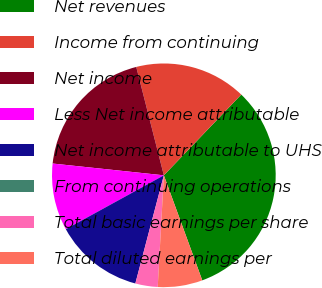Convert chart to OTSL. <chart><loc_0><loc_0><loc_500><loc_500><pie_chart><fcel>Net revenues<fcel>Income from continuing<fcel>Net income<fcel>Less Net income attributable<fcel>Net income attributable to UHS<fcel>From continuing operations<fcel>Total basic earnings per share<fcel>Total diluted earnings per<nl><fcel>32.26%<fcel>16.13%<fcel>19.35%<fcel>9.68%<fcel>12.9%<fcel>0.0%<fcel>3.23%<fcel>6.45%<nl></chart> 